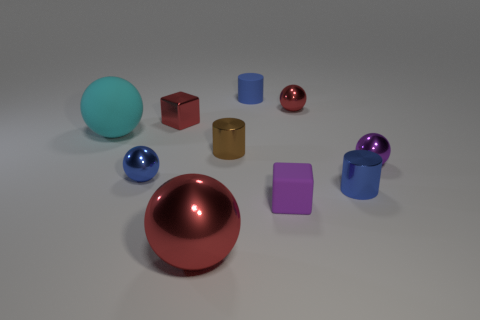Subtract all large rubber balls. How many balls are left? 4 Subtract all purple spheres. How many blue cylinders are left? 2 Subtract all blue spheres. How many spheres are left? 4 Subtract 1 blocks. How many blocks are left? 1 Subtract all gray cylinders. Subtract all gray blocks. How many cylinders are left? 3 Subtract 1 brown cylinders. How many objects are left? 9 Subtract all blocks. How many objects are left? 8 Subtract all purple metallic spheres. Subtract all brown cylinders. How many objects are left? 8 Add 5 brown things. How many brown things are left? 6 Add 9 gray matte things. How many gray matte things exist? 9 